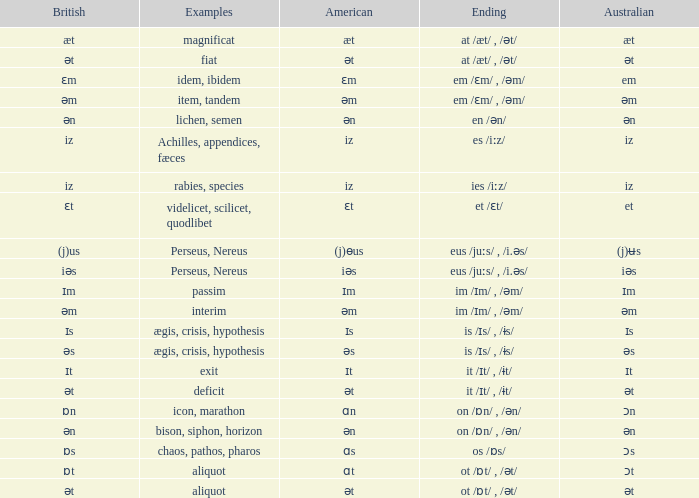Which Australian has British of ɒs? Ɔs. Could you parse the entire table as a dict? {'header': ['British', 'Examples', 'American', 'Ending', 'Australian'], 'rows': [['æt', 'magnificat', 'æt', 'at /æt/ , /ət/', 'æt'], ['ət', 'fiat', 'ət', 'at /æt/ , /ət/', 'ət'], ['ɛm', 'idem, ibidem', 'ɛm', 'em /ɛm/ , /əm/', 'em'], ['əm', 'item, tandem', 'əm', 'em /ɛm/ , /əm/', 'əm'], ['ən', 'lichen, semen', 'ən', 'en /ən/', 'ən'], ['iz', 'Achilles, appendices, fæces', 'iz', 'es /iːz/', 'iz'], ['iz', 'rabies, species', 'iz', 'ies /iːz/', 'iz'], ['ɛt', 'videlicet, scilicet, quodlibet', 'ɛt', 'et /ɛt/', 'et'], ['(j)us', 'Perseus, Nereus', '(j)ɵus', 'eus /juːs/ , /i.əs/', '(j)ʉs'], ['iəs', 'Perseus, Nereus', 'iəs', 'eus /juːs/ , /i.əs/', 'iəs'], ['ɪm', 'passim', 'ɪm', 'im /ɪm/ , /əm/', 'ɪm'], ['əm', 'interim', 'əm', 'im /ɪm/ , /əm/', 'əm'], ['ɪs', 'ægis, crisis, hypothesis', 'ɪs', 'is /ɪs/ , /ɨs/', 'ɪs'], ['əs', 'ægis, crisis, hypothesis', 'əs', 'is /ɪs/ , /ɨs/', 'əs'], ['ɪt', 'exit', 'ɪt', 'it /ɪt/ , /ɨt/', 'ɪt'], ['ət', 'deficit', 'ət', 'it /ɪt/ , /ɨt/', 'ət'], ['ɒn', 'icon, marathon', 'ɑn', 'on /ɒn/ , /ən/', 'ɔn'], ['ən', 'bison, siphon, horizon', 'ən', 'on /ɒn/ , /ən/', 'ən'], ['ɒs', 'chaos, pathos, pharos', 'ɑs', 'os /ɒs/', 'ɔs'], ['ɒt', 'aliquot', 'ɑt', 'ot /ɒt/ , /ət/', 'ɔt'], ['ət', 'aliquot', 'ət', 'ot /ɒt/ , /ət/', 'ət']]} 